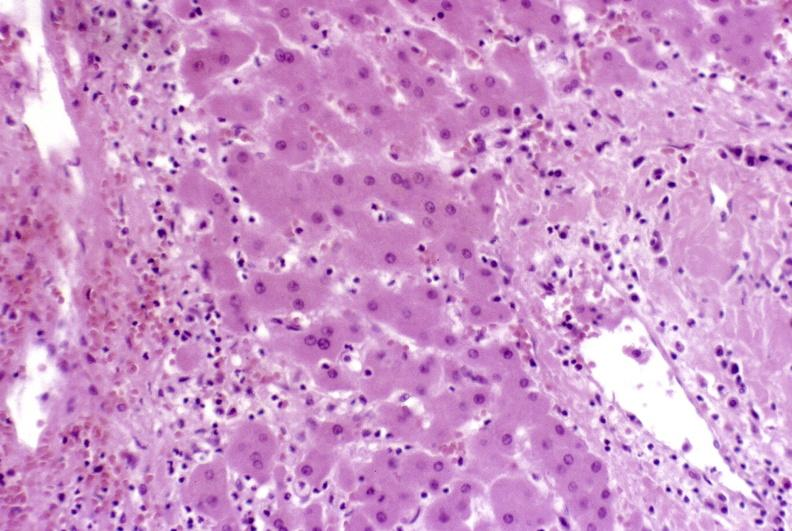does carcinoma show severe acute rejection?
Answer the question using a single word or phrase. No 